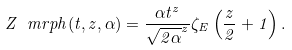<formula> <loc_0><loc_0><loc_500><loc_500>Z _ { \ } m r { p h } ( t , z , \alpha ) = \frac { \alpha t ^ { z } } { \sqrt { 2 \alpha } ^ { z } } \zeta _ { E } \left ( \frac { z } { 2 } + 1 \right ) .</formula> 